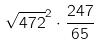<formula> <loc_0><loc_0><loc_500><loc_500>\sqrt { 4 7 2 } ^ { 2 } \cdot \frac { 2 4 7 } { 6 5 }</formula> 